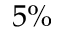Convert formula to latex. <formula><loc_0><loc_0><loc_500><loc_500>5 \%</formula> 